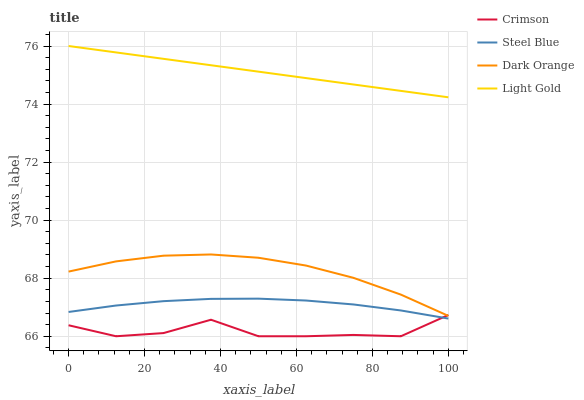Does Crimson have the minimum area under the curve?
Answer yes or no. Yes. Does Light Gold have the maximum area under the curve?
Answer yes or no. Yes. Does Dark Orange have the minimum area under the curve?
Answer yes or no. No. Does Dark Orange have the maximum area under the curve?
Answer yes or no. No. Is Light Gold the smoothest?
Answer yes or no. Yes. Is Crimson the roughest?
Answer yes or no. Yes. Is Dark Orange the smoothest?
Answer yes or no. No. Is Dark Orange the roughest?
Answer yes or no. No. Does Dark Orange have the lowest value?
Answer yes or no. No. Does Light Gold have the highest value?
Answer yes or no. Yes. Does Dark Orange have the highest value?
Answer yes or no. No. Is Dark Orange less than Light Gold?
Answer yes or no. Yes. Is Dark Orange greater than Steel Blue?
Answer yes or no. Yes. Does Crimson intersect Steel Blue?
Answer yes or no. Yes. Is Crimson less than Steel Blue?
Answer yes or no. No. Is Crimson greater than Steel Blue?
Answer yes or no. No. Does Dark Orange intersect Light Gold?
Answer yes or no. No. 